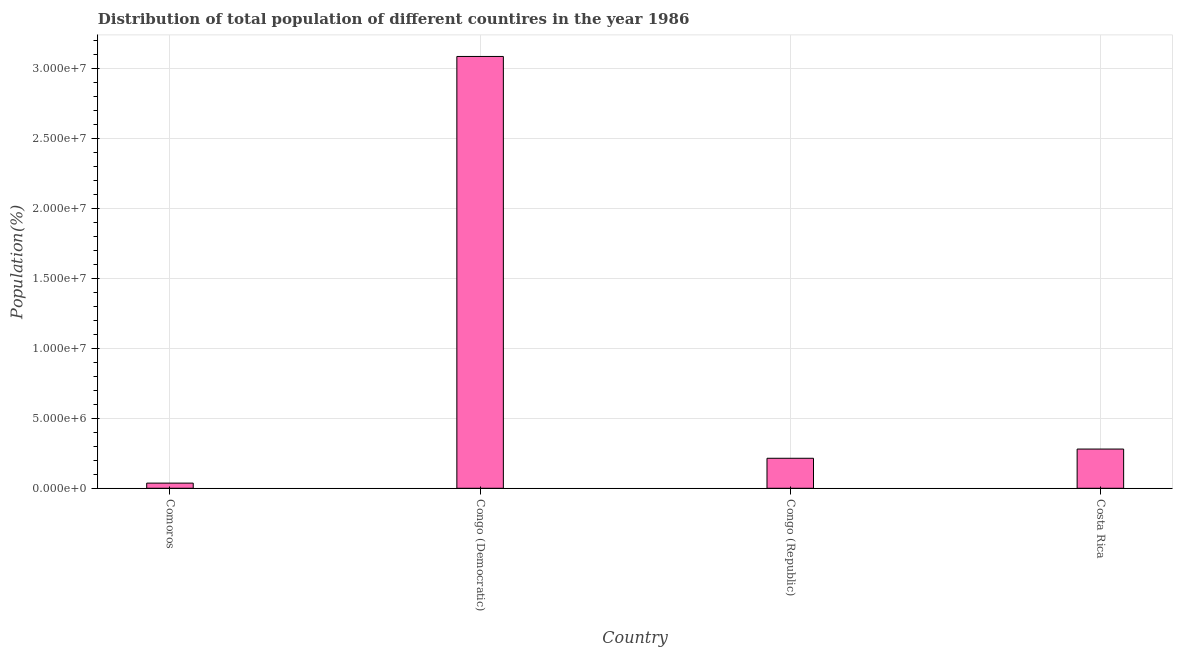Does the graph contain grids?
Keep it short and to the point. Yes. What is the title of the graph?
Provide a short and direct response. Distribution of total population of different countires in the year 1986. What is the label or title of the Y-axis?
Give a very brief answer. Population(%). What is the population in Comoros?
Your response must be concise. 3.68e+05. Across all countries, what is the maximum population?
Make the answer very short. 3.08e+07. Across all countries, what is the minimum population?
Provide a short and direct response. 3.68e+05. In which country was the population maximum?
Provide a short and direct response. Congo (Democratic). In which country was the population minimum?
Provide a succinct answer. Comoros. What is the sum of the population?
Offer a very short reply. 3.61e+07. What is the difference between the population in Congo (Republic) and Costa Rica?
Give a very brief answer. -6.58e+05. What is the average population per country?
Provide a short and direct response. 9.04e+06. What is the median population?
Keep it short and to the point. 2.47e+06. What is the ratio of the population in Congo (Democratic) to that in Congo (Republic)?
Your answer should be compact. 14.39. What is the difference between the highest and the second highest population?
Give a very brief answer. 2.80e+07. Is the sum of the population in Comoros and Congo (Democratic) greater than the maximum population across all countries?
Give a very brief answer. Yes. What is the difference between the highest and the lowest population?
Provide a succinct answer. 3.05e+07. In how many countries, is the population greater than the average population taken over all countries?
Your answer should be very brief. 1. Are all the bars in the graph horizontal?
Your answer should be very brief. No. How many countries are there in the graph?
Your answer should be compact. 4. What is the difference between two consecutive major ticks on the Y-axis?
Provide a succinct answer. 5.00e+06. Are the values on the major ticks of Y-axis written in scientific E-notation?
Give a very brief answer. Yes. What is the Population(%) of Comoros?
Your answer should be compact. 3.68e+05. What is the Population(%) of Congo (Democratic)?
Make the answer very short. 3.08e+07. What is the Population(%) of Congo (Republic)?
Make the answer very short. 2.14e+06. What is the Population(%) of Costa Rica?
Your answer should be compact. 2.80e+06. What is the difference between the Population(%) in Comoros and Congo (Democratic)?
Provide a succinct answer. -3.05e+07. What is the difference between the Population(%) in Comoros and Congo (Republic)?
Provide a succinct answer. -1.77e+06. What is the difference between the Population(%) in Comoros and Costa Rica?
Provide a succinct answer. -2.43e+06. What is the difference between the Population(%) in Congo (Democratic) and Congo (Republic)?
Provide a succinct answer. 2.87e+07. What is the difference between the Population(%) in Congo (Democratic) and Costa Rica?
Provide a succinct answer. 2.80e+07. What is the difference between the Population(%) in Congo (Republic) and Costa Rica?
Offer a very short reply. -6.58e+05. What is the ratio of the Population(%) in Comoros to that in Congo (Democratic)?
Give a very brief answer. 0.01. What is the ratio of the Population(%) in Comoros to that in Congo (Republic)?
Make the answer very short. 0.17. What is the ratio of the Population(%) in Comoros to that in Costa Rica?
Make the answer very short. 0.13. What is the ratio of the Population(%) in Congo (Democratic) to that in Congo (Republic)?
Your response must be concise. 14.39. What is the ratio of the Population(%) in Congo (Democratic) to that in Costa Rica?
Make the answer very short. 11.01. What is the ratio of the Population(%) in Congo (Republic) to that in Costa Rica?
Provide a short and direct response. 0.77. 